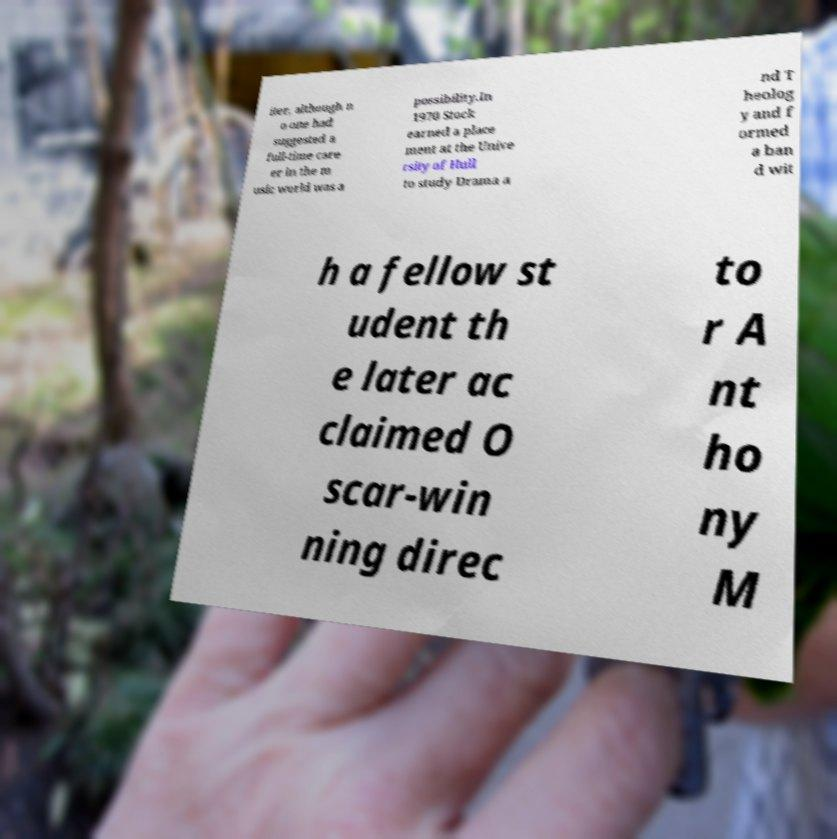Could you assist in decoding the text presented in this image and type it out clearly? iter, although n o one had suggested a full-time care er in the m usic world was a possibility.In 1970 Stock earned a place ment at the Unive rsity of Hull to study Drama a nd T heolog y and f ormed a ban d wit h a fellow st udent th e later ac claimed O scar-win ning direc to r A nt ho ny M 